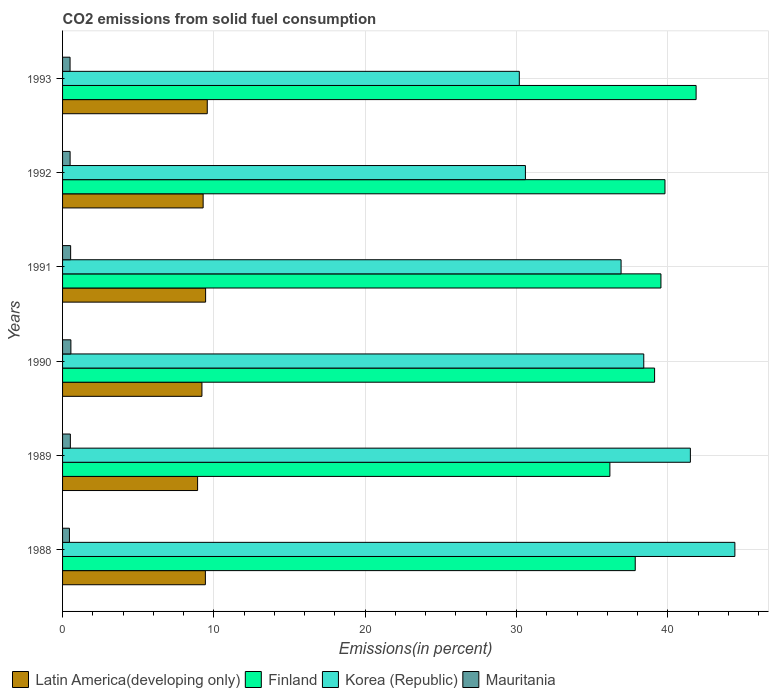How many groups of bars are there?
Your answer should be very brief. 6. Are the number of bars on each tick of the Y-axis equal?
Provide a short and direct response. Yes. What is the total CO2 emitted in Korea (Republic) in 1990?
Give a very brief answer. 38.41. Across all years, what is the maximum total CO2 emitted in Finland?
Provide a succinct answer. 41.87. Across all years, what is the minimum total CO2 emitted in Mauritania?
Give a very brief answer. 0.45. In which year was the total CO2 emitted in Korea (Republic) maximum?
Give a very brief answer. 1988. In which year was the total CO2 emitted in Mauritania minimum?
Provide a short and direct response. 1988. What is the total total CO2 emitted in Finland in the graph?
Offer a very short reply. 234.37. What is the difference between the total CO2 emitted in Finland in 1988 and that in 1991?
Your response must be concise. -1.7. What is the difference between the total CO2 emitted in Latin America(developing only) in 1993 and the total CO2 emitted in Korea (Republic) in 1988?
Ensure brevity in your answer.  -34.87. What is the average total CO2 emitted in Korea (Republic) per year?
Offer a terse response. 37. In the year 1992, what is the difference between the total CO2 emitted in Korea (Republic) and total CO2 emitted in Mauritania?
Provide a short and direct response. 30.09. What is the ratio of the total CO2 emitted in Latin America(developing only) in 1988 to that in 1991?
Make the answer very short. 1. Is the difference between the total CO2 emitted in Korea (Republic) in 1989 and 1991 greater than the difference between the total CO2 emitted in Mauritania in 1989 and 1991?
Your answer should be very brief. Yes. What is the difference between the highest and the second highest total CO2 emitted in Finland?
Ensure brevity in your answer.  2.06. What is the difference between the highest and the lowest total CO2 emitted in Korea (Republic)?
Ensure brevity in your answer.  14.25. Is the sum of the total CO2 emitted in Finland in 1988 and 1989 greater than the maximum total CO2 emitted in Mauritania across all years?
Your answer should be very brief. Yes. What does the 4th bar from the top in 1988 represents?
Keep it short and to the point. Latin America(developing only). What does the 4th bar from the bottom in 1991 represents?
Your answer should be very brief. Mauritania. How many bars are there?
Keep it short and to the point. 24. Are all the bars in the graph horizontal?
Provide a short and direct response. Yes. What is the difference between two consecutive major ticks on the X-axis?
Provide a short and direct response. 10. Are the values on the major ticks of X-axis written in scientific E-notation?
Your response must be concise. No. Where does the legend appear in the graph?
Ensure brevity in your answer.  Bottom left. How many legend labels are there?
Offer a very short reply. 4. How are the legend labels stacked?
Give a very brief answer. Horizontal. What is the title of the graph?
Your answer should be compact. CO2 emissions from solid fuel consumption. Does "Upper middle income" appear as one of the legend labels in the graph?
Provide a short and direct response. No. What is the label or title of the X-axis?
Provide a short and direct response. Emissions(in percent). What is the label or title of the Y-axis?
Your response must be concise. Years. What is the Emissions(in percent) of Latin America(developing only) in 1988?
Your response must be concise. 9.44. What is the Emissions(in percent) of Finland in 1988?
Give a very brief answer. 37.85. What is the Emissions(in percent) in Korea (Republic) in 1988?
Give a very brief answer. 44.43. What is the Emissions(in percent) in Mauritania in 1988?
Keep it short and to the point. 0.45. What is the Emissions(in percent) of Latin America(developing only) in 1989?
Keep it short and to the point. 8.92. What is the Emissions(in percent) in Finland in 1989?
Offer a very short reply. 36.17. What is the Emissions(in percent) in Korea (Republic) in 1989?
Your answer should be very brief. 41.49. What is the Emissions(in percent) in Mauritania in 1989?
Your answer should be very brief. 0.51. What is the Emissions(in percent) in Latin America(developing only) in 1990?
Give a very brief answer. 9.21. What is the Emissions(in percent) in Finland in 1990?
Keep it short and to the point. 39.13. What is the Emissions(in percent) in Korea (Republic) in 1990?
Your answer should be compact. 38.41. What is the Emissions(in percent) of Mauritania in 1990?
Ensure brevity in your answer.  0.55. What is the Emissions(in percent) in Latin America(developing only) in 1991?
Provide a succinct answer. 9.45. What is the Emissions(in percent) of Finland in 1991?
Offer a very short reply. 39.55. What is the Emissions(in percent) in Korea (Republic) in 1991?
Make the answer very short. 36.91. What is the Emissions(in percent) of Mauritania in 1991?
Offer a terse response. 0.53. What is the Emissions(in percent) of Latin America(developing only) in 1992?
Your answer should be very brief. 9.29. What is the Emissions(in percent) in Finland in 1992?
Offer a very short reply. 39.81. What is the Emissions(in percent) in Korea (Republic) in 1992?
Keep it short and to the point. 30.59. What is the Emissions(in percent) in Mauritania in 1992?
Your answer should be very brief. 0.5. What is the Emissions(in percent) in Latin America(developing only) in 1993?
Ensure brevity in your answer.  9.56. What is the Emissions(in percent) in Finland in 1993?
Keep it short and to the point. 41.87. What is the Emissions(in percent) in Korea (Republic) in 1993?
Offer a very short reply. 30.19. What is the Emissions(in percent) of Mauritania in 1993?
Make the answer very short. 0.5. Across all years, what is the maximum Emissions(in percent) in Latin America(developing only)?
Offer a terse response. 9.56. Across all years, what is the maximum Emissions(in percent) in Finland?
Offer a terse response. 41.87. Across all years, what is the maximum Emissions(in percent) of Korea (Republic)?
Provide a short and direct response. 44.43. Across all years, what is the maximum Emissions(in percent) in Mauritania?
Make the answer very short. 0.55. Across all years, what is the minimum Emissions(in percent) of Latin America(developing only)?
Your answer should be very brief. 8.92. Across all years, what is the minimum Emissions(in percent) in Finland?
Your response must be concise. 36.17. Across all years, what is the minimum Emissions(in percent) of Korea (Republic)?
Provide a succinct answer. 30.19. Across all years, what is the minimum Emissions(in percent) of Mauritania?
Provide a succinct answer. 0.45. What is the total Emissions(in percent) of Latin America(developing only) in the graph?
Offer a very short reply. 55.88. What is the total Emissions(in percent) of Finland in the graph?
Make the answer very short. 234.37. What is the total Emissions(in percent) in Korea (Republic) in the graph?
Offer a very short reply. 222.02. What is the total Emissions(in percent) in Mauritania in the graph?
Make the answer very short. 3.05. What is the difference between the Emissions(in percent) of Latin America(developing only) in 1988 and that in 1989?
Give a very brief answer. 0.51. What is the difference between the Emissions(in percent) of Finland in 1988 and that in 1989?
Give a very brief answer. 1.68. What is the difference between the Emissions(in percent) of Korea (Republic) in 1988 and that in 1989?
Keep it short and to the point. 2.94. What is the difference between the Emissions(in percent) of Mauritania in 1988 and that in 1989?
Ensure brevity in your answer.  -0.06. What is the difference between the Emissions(in percent) in Latin America(developing only) in 1988 and that in 1990?
Your answer should be compact. 0.23. What is the difference between the Emissions(in percent) of Finland in 1988 and that in 1990?
Give a very brief answer. -1.28. What is the difference between the Emissions(in percent) in Korea (Republic) in 1988 and that in 1990?
Your answer should be compact. 6.02. What is the difference between the Emissions(in percent) of Mauritania in 1988 and that in 1990?
Offer a very short reply. -0.1. What is the difference between the Emissions(in percent) in Latin America(developing only) in 1988 and that in 1991?
Provide a short and direct response. -0.02. What is the difference between the Emissions(in percent) in Finland in 1988 and that in 1991?
Make the answer very short. -1.7. What is the difference between the Emissions(in percent) of Korea (Republic) in 1988 and that in 1991?
Make the answer very short. 7.52. What is the difference between the Emissions(in percent) of Mauritania in 1988 and that in 1991?
Your answer should be compact. -0.08. What is the difference between the Emissions(in percent) in Latin America(developing only) in 1988 and that in 1992?
Your answer should be compact. 0.15. What is the difference between the Emissions(in percent) in Finland in 1988 and that in 1992?
Your answer should be very brief. -1.96. What is the difference between the Emissions(in percent) in Korea (Republic) in 1988 and that in 1992?
Ensure brevity in your answer.  13.84. What is the difference between the Emissions(in percent) of Mauritania in 1988 and that in 1992?
Offer a very short reply. -0.04. What is the difference between the Emissions(in percent) of Latin America(developing only) in 1988 and that in 1993?
Provide a short and direct response. -0.12. What is the difference between the Emissions(in percent) in Finland in 1988 and that in 1993?
Keep it short and to the point. -4.02. What is the difference between the Emissions(in percent) of Korea (Republic) in 1988 and that in 1993?
Your response must be concise. 14.25. What is the difference between the Emissions(in percent) of Mauritania in 1988 and that in 1993?
Your answer should be compact. -0.04. What is the difference between the Emissions(in percent) of Latin America(developing only) in 1989 and that in 1990?
Provide a short and direct response. -0.29. What is the difference between the Emissions(in percent) in Finland in 1989 and that in 1990?
Provide a short and direct response. -2.95. What is the difference between the Emissions(in percent) in Korea (Republic) in 1989 and that in 1990?
Your answer should be very brief. 3.08. What is the difference between the Emissions(in percent) in Mauritania in 1989 and that in 1990?
Keep it short and to the point. -0.04. What is the difference between the Emissions(in percent) of Latin America(developing only) in 1989 and that in 1991?
Your answer should be compact. -0.53. What is the difference between the Emissions(in percent) of Finland in 1989 and that in 1991?
Make the answer very short. -3.37. What is the difference between the Emissions(in percent) of Korea (Republic) in 1989 and that in 1991?
Your response must be concise. 4.58. What is the difference between the Emissions(in percent) in Mauritania in 1989 and that in 1991?
Offer a very short reply. -0.02. What is the difference between the Emissions(in percent) in Latin America(developing only) in 1989 and that in 1992?
Provide a short and direct response. -0.37. What is the difference between the Emissions(in percent) in Finland in 1989 and that in 1992?
Your answer should be compact. -3.64. What is the difference between the Emissions(in percent) in Korea (Republic) in 1989 and that in 1992?
Keep it short and to the point. 10.9. What is the difference between the Emissions(in percent) of Mauritania in 1989 and that in 1992?
Give a very brief answer. 0.02. What is the difference between the Emissions(in percent) in Latin America(developing only) in 1989 and that in 1993?
Offer a terse response. -0.64. What is the difference between the Emissions(in percent) in Finland in 1989 and that in 1993?
Your answer should be very brief. -5.7. What is the difference between the Emissions(in percent) in Korea (Republic) in 1989 and that in 1993?
Ensure brevity in your answer.  11.3. What is the difference between the Emissions(in percent) of Mauritania in 1989 and that in 1993?
Your answer should be compact. 0.02. What is the difference between the Emissions(in percent) of Latin America(developing only) in 1990 and that in 1991?
Ensure brevity in your answer.  -0.24. What is the difference between the Emissions(in percent) in Finland in 1990 and that in 1991?
Your answer should be very brief. -0.42. What is the difference between the Emissions(in percent) in Korea (Republic) in 1990 and that in 1991?
Offer a terse response. 1.5. What is the difference between the Emissions(in percent) in Mauritania in 1990 and that in 1991?
Your response must be concise. 0.02. What is the difference between the Emissions(in percent) in Latin America(developing only) in 1990 and that in 1992?
Provide a succinct answer. -0.08. What is the difference between the Emissions(in percent) in Finland in 1990 and that in 1992?
Make the answer very short. -0.69. What is the difference between the Emissions(in percent) in Korea (Republic) in 1990 and that in 1992?
Provide a short and direct response. 7.82. What is the difference between the Emissions(in percent) of Mauritania in 1990 and that in 1992?
Provide a succinct answer. 0.05. What is the difference between the Emissions(in percent) of Latin America(developing only) in 1990 and that in 1993?
Your answer should be very brief. -0.35. What is the difference between the Emissions(in percent) in Finland in 1990 and that in 1993?
Offer a terse response. -2.74. What is the difference between the Emissions(in percent) in Korea (Republic) in 1990 and that in 1993?
Your answer should be compact. 8.22. What is the difference between the Emissions(in percent) in Mauritania in 1990 and that in 1993?
Offer a terse response. 0.05. What is the difference between the Emissions(in percent) in Latin America(developing only) in 1991 and that in 1992?
Keep it short and to the point. 0.16. What is the difference between the Emissions(in percent) in Finland in 1991 and that in 1992?
Ensure brevity in your answer.  -0.27. What is the difference between the Emissions(in percent) of Korea (Republic) in 1991 and that in 1992?
Keep it short and to the point. 6.32. What is the difference between the Emissions(in percent) in Mauritania in 1991 and that in 1992?
Keep it short and to the point. 0.03. What is the difference between the Emissions(in percent) of Latin America(developing only) in 1991 and that in 1993?
Give a very brief answer. -0.11. What is the difference between the Emissions(in percent) in Finland in 1991 and that in 1993?
Your answer should be very brief. -2.32. What is the difference between the Emissions(in percent) of Korea (Republic) in 1991 and that in 1993?
Offer a very short reply. 6.73. What is the difference between the Emissions(in percent) in Mauritania in 1991 and that in 1993?
Offer a very short reply. 0.04. What is the difference between the Emissions(in percent) in Latin America(developing only) in 1992 and that in 1993?
Ensure brevity in your answer.  -0.27. What is the difference between the Emissions(in percent) in Finland in 1992 and that in 1993?
Your answer should be very brief. -2.06. What is the difference between the Emissions(in percent) in Korea (Republic) in 1992 and that in 1993?
Make the answer very short. 0.4. What is the difference between the Emissions(in percent) of Mauritania in 1992 and that in 1993?
Offer a terse response. 0. What is the difference between the Emissions(in percent) of Latin America(developing only) in 1988 and the Emissions(in percent) of Finland in 1989?
Your answer should be very brief. -26.73. What is the difference between the Emissions(in percent) of Latin America(developing only) in 1988 and the Emissions(in percent) of Korea (Republic) in 1989?
Ensure brevity in your answer.  -32.05. What is the difference between the Emissions(in percent) of Latin America(developing only) in 1988 and the Emissions(in percent) of Mauritania in 1989?
Keep it short and to the point. 8.92. What is the difference between the Emissions(in percent) of Finland in 1988 and the Emissions(in percent) of Korea (Republic) in 1989?
Your answer should be very brief. -3.64. What is the difference between the Emissions(in percent) of Finland in 1988 and the Emissions(in percent) of Mauritania in 1989?
Provide a short and direct response. 37.33. What is the difference between the Emissions(in percent) of Korea (Republic) in 1988 and the Emissions(in percent) of Mauritania in 1989?
Offer a terse response. 43.92. What is the difference between the Emissions(in percent) of Latin America(developing only) in 1988 and the Emissions(in percent) of Finland in 1990?
Your answer should be very brief. -29.69. What is the difference between the Emissions(in percent) in Latin America(developing only) in 1988 and the Emissions(in percent) in Korea (Republic) in 1990?
Your response must be concise. -28.97. What is the difference between the Emissions(in percent) in Latin America(developing only) in 1988 and the Emissions(in percent) in Mauritania in 1990?
Provide a short and direct response. 8.89. What is the difference between the Emissions(in percent) in Finland in 1988 and the Emissions(in percent) in Korea (Republic) in 1990?
Your answer should be very brief. -0.56. What is the difference between the Emissions(in percent) of Finland in 1988 and the Emissions(in percent) of Mauritania in 1990?
Your answer should be compact. 37.3. What is the difference between the Emissions(in percent) of Korea (Republic) in 1988 and the Emissions(in percent) of Mauritania in 1990?
Offer a terse response. 43.88. What is the difference between the Emissions(in percent) of Latin America(developing only) in 1988 and the Emissions(in percent) of Finland in 1991?
Ensure brevity in your answer.  -30.11. What is the difference between the Emissions(in percent) in Latin America(developing only) in 1988 and the Emissions(in percent) in Korea (Republic) in 1991?
Make the answer very short. -27.47. What is the difference between the Emissions(in percent) of Latin America(developing only) in 1988 and the Emissions(in percent) of Mauritania in 1991?
Your answer should be compact. 8.9. What is the difference between the Emissions(in percent) in Finland in 1988 and the Emissions(in percent) in Korea (Republic) in 1991?
Make the answer very short. 0.94. What is the difference between the Emissions(in percent) of Finland in 1988 and the Emissions(in percent) of Mauritania in 1991?
Keep it short and to the point. 37.31. What is the difference between the Emissions(in percent) of Korea (Republic) in 1988 and the Emissions(in percent) of Mauritania in 1991?
Your answer should be very brief. 43.9. What is the difference between the Emissions(in percent) of Latin America(developing only) in 1988 and the Emissions(in percent) of Finland in 1992?
Your response must be concise. -30.37. What is the difference between the Emissions(in percent) of Latin America(developing only) in 1988 and the Emissions(in percent) of Korea (Republic) in 1992?
Offer a terse response. -21.15. What is the difference between the Emissions(in percent) of Latin America(developing only) in 1988 and the Emissions(in percent) of Mauritania in 1992?
Your answer should be compact. 8.94. What is the difference between the Emissions(in percent) in Finland in 1988 and the Emissions(in percent) in Korea (Republic) in 1992?
Offer a very short reply. 7.26. What is the difference between the Emissions(in percent) of Finland in 1988 and the Emissions(in percent) of Mauritania in 1992?
Offer a terse response. 37.35. What is the difference between the Emissions(in percent) in Korea (Republic) in 1988 and the Emissions(in percent) in Mauritania in 1992?
Your response must be concise. 43.93. What is the difference between the Emissions(in percent) of Latin America(developing only) in 1988 and the Emissions(in percent) of Finland in 1993?
Give a very brief answer. -32.43. What is the difference between the Emissions(in percent) in Latin America(developing only) in 1988 and the Emissions(in percent) in Korea (Republic) in 1993?
Keep it short and to the point. -20.75. What is the difference between the Emissions(in percent) of Latin America(developing only) in 1988 and the Emissions(in percent) of Mauritania in 1993?
Provide a short and direct response. 8.94. What is the difference between the Emissions(in percent) of Finland in 1988 and the Emissions(in percent) of Korea (Republic) in 1993?
Provide a succinct answer. 7.66. What is the difference between the Emissions(in percent) in Finland in 1988 and the Emissions(in percent) in Mauritania in 1993?
Keep it short and to the point. 37.35. What is the difference between the Emissions(in percent) in Korea (Republic) in 1988 and the Emissions(in percent) in Mauritania in 1993?
Ensure brevity in your answer.  43.94. What is the difference between the Emissions(in percent) in Latin America(developing only) in 1989 and the Emissions(in percent) in Finland in 1990?
Offer a very short reply. -30.2. What is the difference between the Emissions(in percent) of Latin America(developing only) in 1989 and the Emissions(in percent) of Korea (Republic) in 1990?
Keep it short and to the point. -29.49. What is the difference between the Emissions(in percent) of Latin America(developing only) in 1989 and the Emissions(in percent) of Mauritania in 1990?
Offer a terse response. 8.37. What is the difference between the Emissions(in percent) in Finland in 1989 and the Emissions(in percent) in Korea (Republic) in 1990?
Provide a short and direct response. -2.24. What is the difference between the Emissions(in percent) of Finland in 1989 and the Emissions(in percent) of Mauritania in 1990?
Provide a succinct answer. 35.62. What is the difference between the Emissions(in percent) of Korea (Republic) in 1989 and the Emissions(in percent) of Mauritania in 1990?
Provide a short and direct response. 40.94. What is the difference between the Emissions(in percent) of Latin America(developing only) in 1989 and the Emissions(in percent) of Finland in 1991?
Keep it short and to the point. -30.62. What is the difference between the Emissions(in percent) of Latin America(developing only) in 1989 and the Emissions(in percent) of Korea (Republic) in 1991?
Your answer should be very brief. -27.99. What is the difference between the Emissions(in percent) of Latin America(developing only) in 1989 and the Emissions(in percent) of Mauritania in 1991?
Offer a very short reply. 8.39. What is the difference between the Emissions(in percent) of Finland in 1989 and the Emissions(in percent) of Korea (Republic) in 1991?
Your response must be concise. -0.74. What is the difference between the Emissions(in percent) of Finland in 1989 and the Emissions(in percent) of Mauritania in 1991?
Offer a terse response. 35.64. What is the difference between the Emissions(in percent) of Korea (Republic) in 1989 and the Emissions(in percent) of Mauritania in 1991?
Your response must be concise. 40.96. What is the difference between the Emissions(in percent) in Latin America(developing only) in 1989 and the Emissions(in percent) in Finland in 1992?
Provide a short and direct response. -30.89. What is the difference between the Emissions(in percent) of Latin America(developing only) in 1989 and the Emissions(in percent) of Korea (Republic) in 1992?
Offer a terse response. -21.67. What is the difference between the Emissions(in percent) of Latin America(developing only) in 1989 and the Emissions(in percent) of Mauritania in 1992?
Give a very brief answer. 8.42. What is the difference between the Emissions(in percent) of Finland in 1989 and the Emissions(in percent) of Korea (Republic) in 1992?
Ensure brevity in your answer.  5.58. What is the difference between the Emissions(in percent) of Finland in 1989 and the Emissions(in percent) of Mauritania in 1992?
Your answer should be very brief. 35.67. What is the difference between the Emissions(in percent) in Korea (Republic) in 1989 and the Emissions(in percent) in Mauritania in 1992?
Your answer should be compact. 40.99. What is the difference between the Emissions(in percent) of Latin America(developing only) in 1989 and the Emissions(in percent) of Finland in 1993?
Provide a short and direct response. -32.95. What is the difference between the Emissions(in percent) of Latin America(developing only) in 1989 and the Emissions(in percent) of Korea (Republic) in 1993?
Your response must be concise. -21.26. What is the difference between the Emissions(in percent) in Latin America(developing only) in 1989 and the Emissions(in percent) in Mauritania in 1993?
Your answer should be very brief. 8.43. What is the difference between the Emissions(in percent) of Finland in 1989 and the Emissions(in percent) of Korea (Republic) in 1993?
Make the answer very short. 5.99. What is the difference between the Emissions(in percent) of Finland in 1989 and the Emissions(in percent) of Mauritania in 1993?
Your answer should be very brief. 35.68. What is the difference between the Emissions(in percent) of Korea (Republic) in 1989 and the Emissions(in percent) of Mauritania in 1993?
Your answer should be very brief. 40.99. What is the difference between the Emissions(in percent) in Latin America(developing only) in 1990 and the Emissions(in percent) in Finland in 1991?
Your response must be concise. -30.33. What is the difference between the Emissions(in percent) in Latin America(developing only) in 1990 and the Emissions(in percent) in Korea (Republic) in 1991?
Your response must be concise. -27.7. What is the difference between the Emissions(in percent) of Latin America(developing only) in 1990 and the Emissions(in percent) of Mauritania in 1991?
Give a very brief answer. 8.68. What is the difference between the Emissions(in percent) of Finland in 1990 and the Emissions(in percent) of Korea (Republic) in 1991?
Ensure brevity in your answer.  2.21. What is the difference between the Emissions(in percent) in Finland in 1990 and the Emissions(in percent) in Mauritania in 1991?
Keep it short and to the point. 38.59. What is the difference between the Emissions(in percent) in Korea (Republic) in 1990 and the Emissions(in percent) in Mauritania in 1991?
Give a very brief answer. 37.88. What is the difference between the Emissions(in percent) of Latin America(developing only) in 1990 and the Emissions(in percent) of Finland in 1992?
Your answer should be very brief. -30.6. What is the difference between the Emissions(in percent) in Latin America(developing only) in 1990 and the Emissions(in percent) in Korea (Republic) in 1992?
Offer a very short reply. -21.38. What is the difference between the Emissions(in percent) of Latin America(developing only) in 1990 and the Emissions(in percent) of Mauritania in 1992?
Provide a succinct answer. 8.71. What is the difference between the Emissions(in percent) in Finland in 1990 and the Emissions(in percent) in Korea (Republic) in 1992?
Provide a short and direct response. 8.54. What is the difference between the Emissions(in percent) in Finland in 1990 and the Emissions(in percent) in Mauritania in 1992?
Keep it short and to the point. 38.63. What is the difference between the Emissions(in percent) of Korea (Republic) in 1990 and the Emissions(in percent) of Mauritania in 1992?
Your response must be concise. 37.91. What is the difference between the Emissions(in percent) in Latin America(developing only) in 1990 and the Emissions(in percent) in Finland in 1993?
Provide a succinct answer. -32.66. What is the difference between the Emissions(in percent) in Latin America(developing only) in 1990 and the Emissions(in percent) in Korea (Republic) in 1993?
Provide a short and direct response. -20.98. What is the difference between the Emissions(in percent) in Latin America(developing only) in 1990 and the Emissions(in percent) in Mauritania in 1993?
Offer a very short reply. 8.71. What is the difference between the Emissions(in percent) in Finland in 1990 and the Emissions(in percent) in Korea (Republic) in 1993?
Your answer should be compact. 8.94. What is the difference between the Emissions(in percent) in Finland in 1990 and the Emissions(in percent) in Mauritania in 1993?
Your response must be concise. 38.63. What is the difference between the Emissions(in percent) of Korea (Republic) in 1990 and the Emissions(in percent) of Mauritania in 1993?
Your answer should be compact. 37.91. What is the difference between the Emissions(in percent) in Latin America(developing only) in 1991 and the Emissions(in percent) in Finland in 1992?
Keep it short and to the point. -30.36. What is the difference between the Emissions(in percent) of Latin America(developing only) in 1991 and the Emissions(in percent) of Korea (Republic) in 1992?
Offer a very short reply. -21.14. What is the difference between the Emissions(in percent) in Latin America(developing only) in 1991 and the Emissions(in percent) in Mauritania in 1992?
Keep it short and to the point. 8.95. What is the difference between the Emissions(in percent) of Finland in 1991 and the Emissions(in percent) of Korea (Republic) in 1992?
Provide a short and direct response. 8.96. What is the difference between the Emissions(in percent) of Finland in 1991 and the Emissions(in percent) of Mauritania in 1992?
Offer a terse response. 39.05. What is the difference between the Emissions(in percent) in Korea (Republic) in 1991 and the Emissions(in percent) in Mauritania in 1992?
Offer a terse response. 36.41. What is the difference between the Emissions(in percent) in Latin America(developing only) in 1991 and the Emissions(in percent) in Finland in 1993?
Ensure brevity in your answer.  -32.42. What is the difference between the Emissions(in percent) of Latin America(developing only) in 1991 and the Emissions(in percent) of Korea (Republic) in 1993?
Give a very brief answer. -20.73. What is the difference between the Emissions(in percent) in Latin America(developing only) in 1991 and the Emissions(in percent) in Mauritania in 1993?
Provide a short and direct response. 8.96. What is the difference between the Emissions(in percent) of Finland in 1991 and the Emissions(in percent) of Korea (Republic) in 1993?
Give a very brief answer. 9.36. What is the difference between the Emissions(in percent) in Finland in 1991 and the Emissions(in percent) in Mauritania in 1993?
Provide a short and direct response. 39.05. What is the difference between the Emissions(in percent) in Korea (Republic) in 1991 and the Emissions(in percent) in Mauritania in 1993?
Make the answer very short. 36.42. What is the difference between the Emissions(in percent) of Latin America(developing only) in 1992 and the Emissions(in percent) of Finland in 1993?
Keep it short and to the point. -32.58. What is the difference between the Emissions(in percent) of Latin America(developing only) in 1992 and the Emissions(in percent) of Korea (Republic) in 1993?
Provide a short and direct response. -20.9. What is the difference between the Emissions(in percent) of Latin America(developing only) in 1992 and the Emissions(in percent) of Mauritania in 1993?
Give a very brief answer. 8.79. What is the difference between the Emissions(in percent) in Finland in 1992 and the Emissions(in percent) in Korea (Republic) in 1993?
Your answer should be compact. 9.63. What is the difference between the Emissions(in percent) in Finland in 1992 and the Emissions(in percent) in Mauritania in 1993?
Provide a succinct answer. 39.32. What is the difference between the Emissions(in percent) in Korea (Republic) in 1992 and the Emissions(in percent) in Mauritania in 1993?
Keep it short and to the point. 30.09. What is the average Emissions(in percent) of Latin America(developing only) per year?
Offer a terse response. 9.31. What is the average Emissions(in percent) of Finland per year?
Ensure brevity in your answer.  39.06. What is the average Emissions(in percent) in Korea (Republic) per year?
Provide a succinct answer. 37. What is the average Emissions(in percent) in Mauritania per year?
Your answer should be very brief. 0.51. In the year 1988, what is the difference between the Emissions(in percent) of Latin America(developing only) and Emissions(in percent) of Finland?
Keep it short and to the point. -28.41. In the year 1988, what is the difference between the Emissions(in percent) in Latin America(developing only) and Emissions(in percent) in Korea (Republic)?
Keep it short and to the point. -34.99. In the year 1988, what is the difference between the Emissions(in percent) in Latin America(developing only) and Emissions(in percent) in Mauritania?
Give a very brief answer. 8.98. In the year 1988, what is the difference between the Emissions(in percent) of Finland and Emissions(in percent) of Korea (Republic)?
Offer a terse response. -6.58. In the year 1988, what is the difference between the Emissions(in percent) of Finland and Emissions(in percent) of Mauritania?
Keep it short and to the point. 37.39. In the year 1988, what is the difference between the Emissions(in percent) of Korea (Republic) and Emissions(in percent) of Mauritania?
Offer a terse response. 43.98. In the year 1989, what is the difference between the Emissions(in percent) in Latin America(developing only) and Emissions(in percent) in Finland?
Make the answer very short. -27.25. In the year 1989, what is the difference between the Emissions(in percent) in Latin America(developing only) and Emissions(in percent) in Korea (Republic)?
Provide a short and direct response. -32.57. In the year 1989, what is the difference between the Emissions(in percent) in Latin America(developing only) and Emissions(in percent) in Mauritania?
Keep it short and to the point. 8.41. In the year 1989, what is the difference between the Emissions(in percent) of Finland and Emissions(in percent) of Korea (Republic)?
Provide a short and direct response. -5.32. In the year 1989, what is the difference between the Emissions(in percent) of Finland and Emissions(in percent) of Mauritania?
Your answer should be very brief. 35.66. In the year 1989, what is the difference between the Emissions(in percent) in Korea (Republic) and Emissions(in percent) in Mauritania?
Offer a very short reply. 40.98. In the year 1990, what is the difference between the Emissions(in percent) in Latin America(developing only) and Emissions(in percent) in Finland?
Make the answer very short. -29.92. In the year 1990, what is the difference between the Emissions(in percent) in Latin America(developing only) and Emissions(in percent) in Korea (Republic)?
Your answer should be compact. -29.2. In the year 1990, what is the difference between the Emissions(in percent) in Latin America(developing only) and Emissions(in percent) in Mauritania?
Provide a short and direct response. 8.66. In the year 1990, what is the difference between the Emissions(in percent) in Finland and Emissions(in percent) in Korea (Republic)?
Make the answer very short. 0.72. In the year 1990, what is the difference between the Emissions(in percent) in Finland and Emissions(in percent) in Mauritania?
Your answer should be compact. 38.58. In the year 1990, what is the difference between the Emissions(in percent) in Korea (Republic) and Emissions(in percent) in Mauritania?
Provide a succinct answer. 37.86. In the year 1991, what is the difference between the Emissions(in percent) of Latin America(developing only) and Emissions(in percent) of Finland?
Offer a terse response. -30.09. In the year 1991, what is the difference between the Emissions(in percent) of Latin America(developing only) and Emissions(in percent) of Korea (Republic)?
Your answer should be very brief. -27.46. In the year 1991, what is the difference between the Emissions(in percent) of Latin America(developing only) and Emissions(in percent) of Mauritania?
Your response must be concise. 8.92. In the year 1991, what is the difference between the Emissions(in percent) of Finland and Emissions(in percent) of Korea (Republic)?
Provide a succinct answer. 2.63. In the year 1991, what is the difference between the Emissions(in percent) of Finland and Emissions(in percent) of Mauritania?
Keep it short and to the point. 39.01. In the year 1991, what is the difference between the Emissions(in percent) in Korea (Republic) and Emissions(in percent) in Mauritania?
Your answer should be very brief. 36.38. In the year 1992, what is the difference between the Emissions(in percent) in Latin America(developing only) and Emissions(in percent) in Finland?
Keep it short and to the point. -30.52. In the year 1992, what is the difference between the Emissions(in percent) of Latin America(developing only) and Emissions(in percent) of Korea (Republic)?
Offer a terse response. -21.3. In the year 1992, what is the difference between the Emissions(in percent) in Latin America(developing only) and Emissions(in percent) in Mauritania?
Give a very brief answer. 8.79. In the year 1992, what is the difference between the Emissions(in percent) of Finland and Emissions(in percent) of Korea (Republic)?
Your answer should be very brief. 9.22. In the year 1992, what is the difference between the Emissions(in percent) of Finland and Emissions(in percent) of Mauritania?
Ensure brevity in your answer.  39.31. In the year 1992, what is the difference between the Emissions(in percent) of Korea (Republic) and Emissions(in percent) of Mauritania?
Your answer should be very brief. 30.09. In the year 1993, what is the difference between the Emissions(in percent) in Latin America(developing only) and Emissions(in percent) in Finland?
Give a very brief answer. -32.31. In the year 1993, what is the difference between the Emissions(in percent) of Latin America(developing only) and Emissions(in percent) of Korea (Republic)?
Make the answer very short. -20.62. In the year 1993, what is the difference between the Emissions(in percent) in Latin America(developing only) and Emissions(in percent) in Mauritania?
Offer a terse response. 9.07. In the year 1993, what is the difference between the Emissions(in percent) of Finland and Emissions(in percent) of Korea (Republic)?
Your answer should be compact. 11.68. In the year 1993, what is the difference between the Emissions(in percent) in Finland and Emissions(in percent) in Mauritania?
Keep it short and to the point. 41.37. In the year 1993, what is the difference between the Emissions(in percent) of Korea (Republic) and Emissions(in percent) of Mauritania?
Offer a terse response. 29.69. What is the ratio of the Emissions(in percent) in Latin America(developing only) in 1988 to that in 1989?
Provide a short and direct response. 1.06. What is the ratio of the Emissions(in percent) in Finland in 1988 to that in 1989?
Provide a short and direct response. 1.05. What is the ratio of the Emissions(in percent) of Korea (Republic) in 1988 to that in 1989?
Your response must be concise. 1.07. What is the ratio of the Emissions(in percent) of Mauritania in 1988 to that in 1989?
Make the answer very short. 0.88. What is the ratio of the Emissions(in percent) of Latin America(developing only) in 1988 to that in 1990?
Make the answer very short. 1.02. What is the ratio of the Emissions(in percent) of Finland in 1988 to that in 1990?
Offer a very short reply. 0.97. What is the ratio of the Emissions(in percent) of Korea (Republic) in 1988 to that in 1990?
Give a very brief answer. 1.16. What is the ratio of the Emissions(in percent) in Mauritania in 1988 to that in 1990?
Your answer should be compact. 0.83. What is the ratio of the Emissions(in percent) in Latin America(developing only) in 1988 to that in 1991?
Make the answer very short. 1. What is the ratio of the Emissions(in percent) in Finland in 1988 to that in 1991?
Provide a succinct answer. 0.96. What is the ratio of the Emissions(in percent) in Korea (Republic) in 1988 to that in 1991?
Give a very brief answer. 1.2. What is the ratio of the Emissions(in percent) of Mauritania in 1988 to that in 1991?
Offer a terse response. 0.85. What is the ratio of the Emissions(in percent) of Latin America(developing only) in 1988 to that in 1992?
Offer a terse response. 1.02. What is the ratio of the Emissions(in percent) in Finland in 1988 to that in 1992?
Your answer should be very brief. 0.95. What is the ratio of the Emissions(in percent) of Korea (Republic) in 1988 to that in 1992?
Make the answer very short. 1.45. What is the ratio of the Emissions(in percent) of Mauritania in 1988 to that in 1992?
Your answer should be compact. 0.91. What is the ratio of the Emissions(in percent) in Finland in 1988 to that in 1993?
Offer a very short reply. 0.9. What is the ratio of the Emissions(in percent) in Korea (Republic) in 1988 to that in 1993?
Provide a short and direct response. 1.47. What is the ratio of the Emissions(in percent) of Mauritania in 1988 to that in 1993?
Your answer should be compact. 0.92. What is the ratio of the Emissions(in percent) in Latin America(developing only) in 1989 to that in 1990?
Your answer should be very brief. 0.97. What is the ratio of the Emissions(in percent) in Finland in 1989 to that in 1990?
Provide a short and direct response. 0.92. What is the ratio of the Emissions(in percent) in Korea (Republic) in 1989 to that in 1990?
Provide a short and direct response. 1.08. What is the ratio of the Emissions(in percent) of Mauritania in 1989 to that in 1990?
Provide a succinct answer. 0.94. What is the ratio of the Emissions(in percent) in Latin America(developing only) in 1989 to that in 1991?
Your answer should be very brief. 0.94. What is the ratio of the Emissions(in percent) in Finland in 1989 to that in 1991?
Provide a short and direct response. 0.91. What is the ratio of the Emissions(in percent) in Korea (Republic) in 1989 to that in 1991?
Your answer should be very brief. 1.12. What is the ratio of the Emissions(in percent) in Mauritania in 1989 to that in 1991?
Make the answer very short. 0.97. What is the ratio of the Emissions(in percent) of Latin America(developing only) in 1989 to that in 1992?
Provide a succinct answer. 0.96. What is the ratio of the Emissions(in percent) of Finland in 1989 to that in 1992?
Offer a terse response. 0.91. What is the ratio of the Emissions(in percent) in Korea (Republic) in 1989 to that in 1992?
Provide a succinct answer. 1.36. What is the ratio of the Emissions(in percent) in Mauritania in 1989 to that in 1992?
Your answer should be very brief. 1.03. What is the ratio of the Emissions(in percent) of Latin America(developing only) in 1989 to that in 1993?
Offer a very short reply. 0.93. What is the ratio of the Emissions(in percent) of Finland in 1989 to that in 1993?
Offer a terse response. 0.86. What is the ratio of the Emissions(in percent) in Korea (Republic) in 1989 to that in 1993?
Your response must be concise. 1.37. What is the ratio of the Emissions(in percent) of Mauritania in 1989 to that in 1993?
Your answer should be compact. 1.04. What is the ratio of the Emissions(in percent) in Latin America(developing only) in 1990 to that in 1991?
Provide a succinct answer. 0.97. What is the ratio of the Emissions(in percent) of Finland in 1990 to that in 1991?
Provide a short and direct response. 0.99. What is the ratio of the Emissions(in percent) of Korea (Republic) in 1990 to that in 1991?
Offer a very short reply. 1.04. What is the ratio of the Emissions(in percent) of Mauritania in 1990 to that in 1991?
Offer a very short reply. 1.03. What is the ratio of the Emissions(in percent) of Finland in 1990 to that in 1992?
Ensure brevity in your answer.  0.98. What is the ratio of the Emissions(in percent) in Korea (Republic) in 1990 to that in 1992?
Provide a succinct answer. 1.26. What is the ratio of the Emissions(in percent) of Mauritania in 1990 to that in 1992?
Give a very brief answer. 1.1. What is the ratio of the Emissions(in percent) in Latin America(developing only) in 1990 to that in 1993?
Offer a very short reply. 0.96. What is the ratio of the Emissions(in percent) of Finland in 1990 to that in 1993?
Offer a very short reply. 0.93. What is the ratio of the Emissions(in percent) in Korea (Republic) in 1990 to that in 1993?
Ensure brevity in your answer.  1.27. What is the ratio of the Emissions(in percent) in Mauritania in 1990 to that in 1993?
Provide a short and direct response. 1.11. What is the ratio of the Emissions(in percent) of Latin America(developing only) in 1991 to that in 1992?
Make the answer very short. 1.02. What is the ratio of the Emissions(in percent) in Finland in 1991 to that in 1992?
Your answer should be compact. 0.99. What is the ratio of the Emissions(in percent) in Korea (Republic) in 1991 to that in 1992?
Give a very brief answer. 1.21. What is the ratio of the Emissions(in percent) of Mauritania in 1991 to that in 1992?
Keep it short and to the point. 1.07. What is the ratio of the Emissions(in percent) in Finland in 1991 to that in 1993?
Offer a terse response. 0.94. What is the ratio of the Emissions(in percent) of Korea (Republic) in 1991 to that in 1993?
Offer a terse response. 1.22. What is the ratio of the Emissions(in percent) in Mauritania in 1991 to that in 1993?
Your response must be concise. 1.08. What is the ratio of the Emissions(in percent) in Latin America(developing only) in 1992 to that in 1993?
Ensure brevity in your answer.  0.97. What is the ratio of the Emissions(in percent) of Finland in 1992 to that in 1993?
Offer a terse response. 0.95. What is the ratio of the Emissions(in percent) in Korea (Republic) in 1992 to that in 1993?
Give a very brief answer. 1.01. What is the ratio of the Emissions(in percent) of Mauritania in 1992 to that in 1993?
Your answer should be compact. 1.01. What is the difference between the highest and the second highest Emissions(in percent) in Latin America(developing only)?
Provide a succinct answer. 0.11. What is the difference between the highest and the second highest Emissions(in percent) of Finland?
Your answer should be compact. 2.06. What is the difference between the highest and the second highest Emissions(in percent) of Korea (Republic)?
Ensure brevity in your answer.  2.94. What is the difference between the highest and the second highest Emissions(in percent) in Mauritania?
Provide a short and direct response. 0.02. What is the difference between the highest and the lowest Emissions(in percent) of Latin America(developing only)?
Offer a terse response. 0.64. What is the difference between the highest and the lowest Emissions(in percent) in Finland?
Keep it short and to the point. 5.7. What is the difference between the highest and the lowest Emissions(in percent) of Korea (Republic)?
Provide a succinct answer. 14.25. What is the difference between the highest and the lowest Emissions(in percent) in Mauritania?
Make the answer very short. 0.1. 